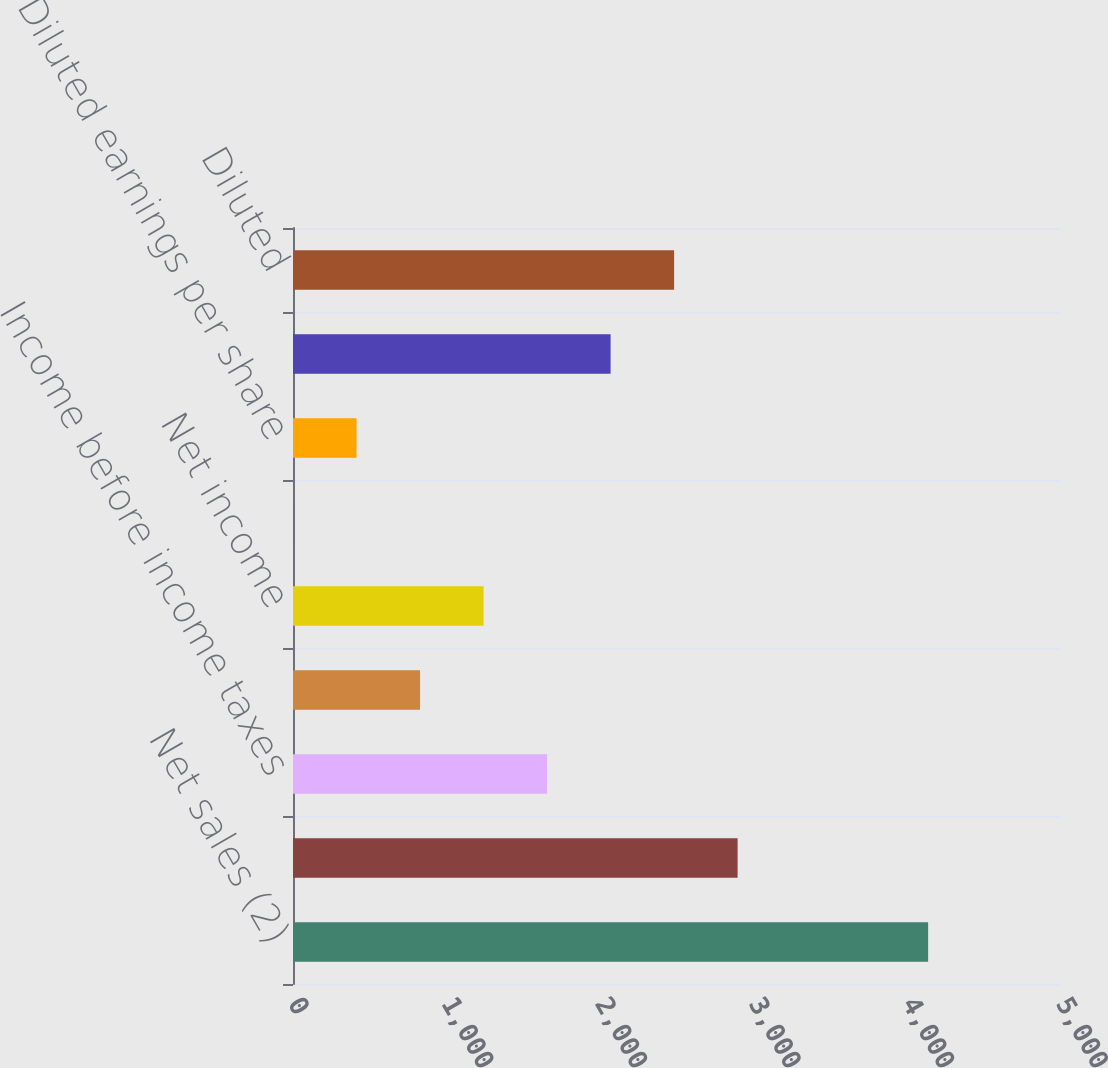Convert chart. <chart><loc_0><loc_0><loc_500><loc_500><bar_chart><fcel>Net sales (2)<fcel>Gross profit<fcel>Income before income taxes<fcel>Provision for income taxes<fcel>Net income<fcel>Basic earnings per share<fcel>Diluted earnings per share<fcel>Basic<fcel>Diluted<nl><fcel>4135<fcel>2894.63<fcel>1654.22<fcel>827.28<fcel>1240.75<fcel>0.34<fcel>413.81<fcel>2067.69<fcel>2481.16<nl></chart> 